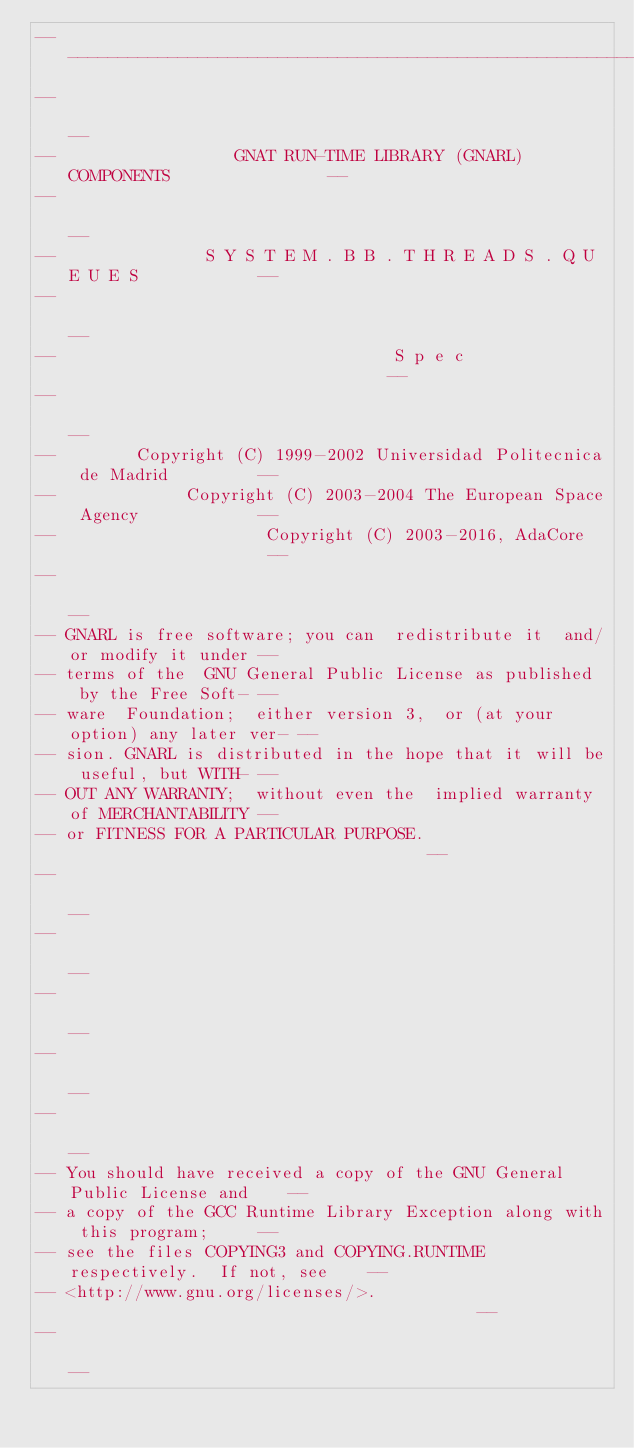Convert code to text. <code><loc_0><loc_0><loc_500><loc_500><_Ada_>------------------------------------------------------------------------------
--                                                                          --
--                  GNAT RUN-TIME LIBRARY (GNARL) COMPONENTS                --
--                                                                          --
--               S Y S T E M . B B . T H R E A D S . Q U E U E S            --
--                                                                          --
--                                  S p e c                                 --
--                                                                          --
--        Copyright (C) 1999-2002 Universidad Politecnica de Madrid         --
--             Copyright (C) 2003-2004 The European Space Agency            --
--                     Copyright (C) 2003-2016, AdaCore                     --
--                                                                          --
-- GNARL is free software; you can  redistribute it  and/or modify it under --
-- terms of the  GNU General Public License as published  by the Free Soft- --
-- ware  Foundation;  either version 3,  or (at your option) any later ver- --
-- sion. GNARL is distributed in the hope that it will be useful, but WITH- --
-- OUT ANY WARRANTY;  without even the  implied warranty of MERCHANTABILITY --
-- or FITNESS FOR A PARTICULAR PURPOSE.                                     --
--                                                                          --
--                                                                          --
--                                                                          --
--                                                                          --
--                                                                          --
-- You should have received a copy of the GNU General Public License and    --
-- a copy of the GCC Runtime Library Exception along with this program;     --
-- see the files COPYING3 and COPYING.RUNTIME respectively.  If not, see    --
-- <http://www.gnu.org/licenses/>.                                          --
--                                                                          --</code> 